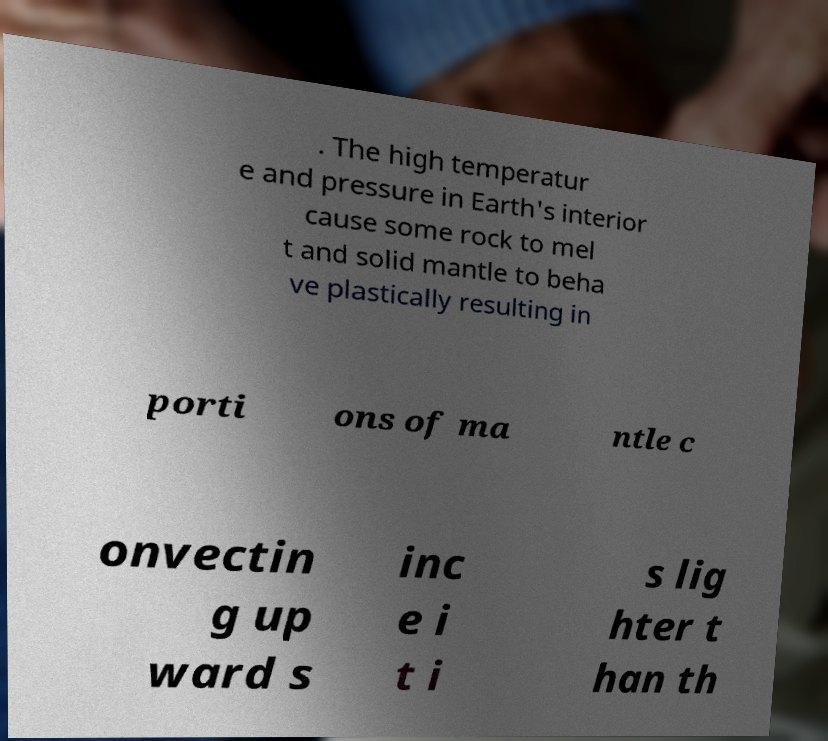What messages or text are displayed in this image? I need them in a readable, typed format. . The high temperatur e and pressure in Earth's interior cause some rock to mel t and solid mantle to beha ve plastically resulting in porti ons of ma ntle c onvectin g up ward s inc e i t i s lig hter t han th 